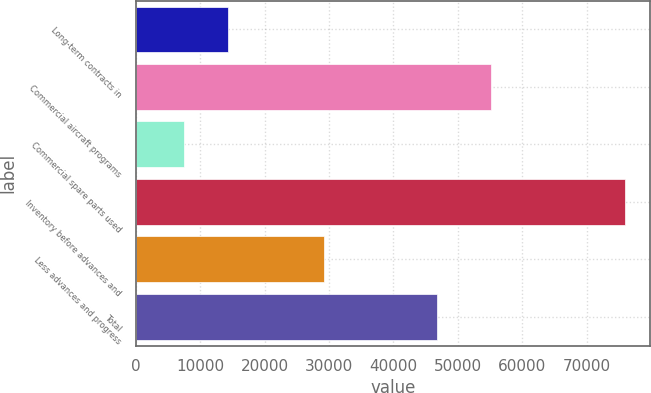Convert chart. <chart><loc_0><loc_0><loc_500><loc_500><bar_chart><fcel>Long-term contracts in<fcel>Commercial aircraft programs<fcel>Commercial spare parts used<fcel>Inventory before advances and<fcel>Less advances and progress<fcel>Total<nl><fcel>14281.1<fcel>55220<fcel>7421<fcel>76022<fcel>29266<fcel>46756<nl></chart> 